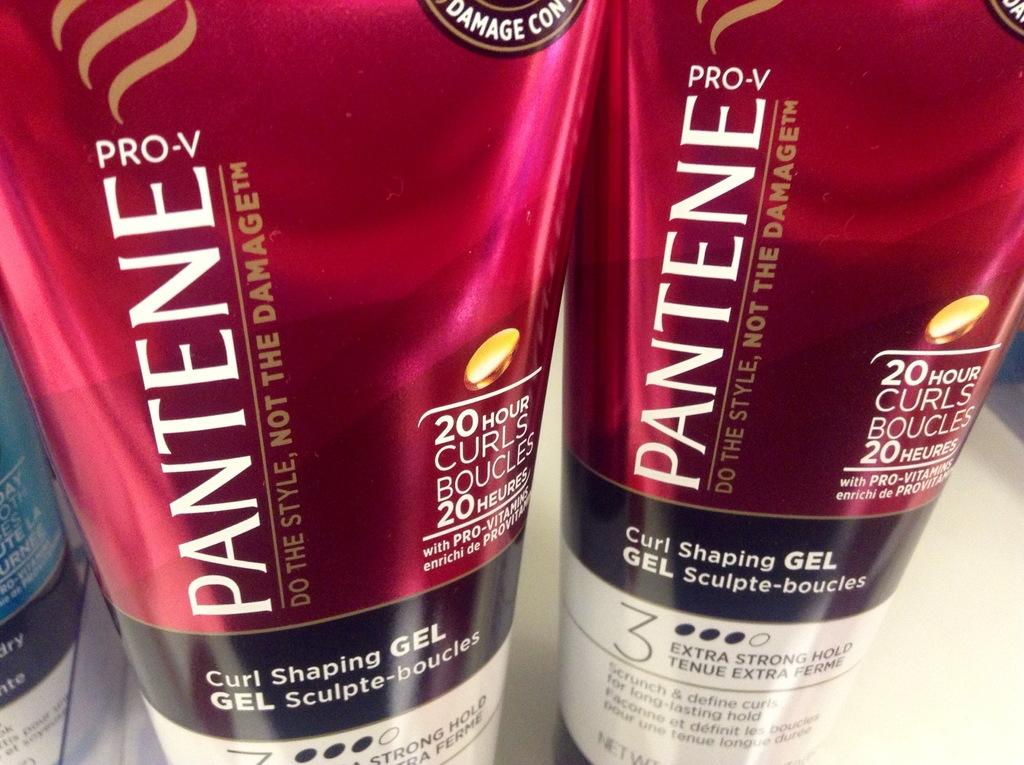<image>
Describe the image concisely. Two bottles of Pantene Pro-V products sit side by side. 